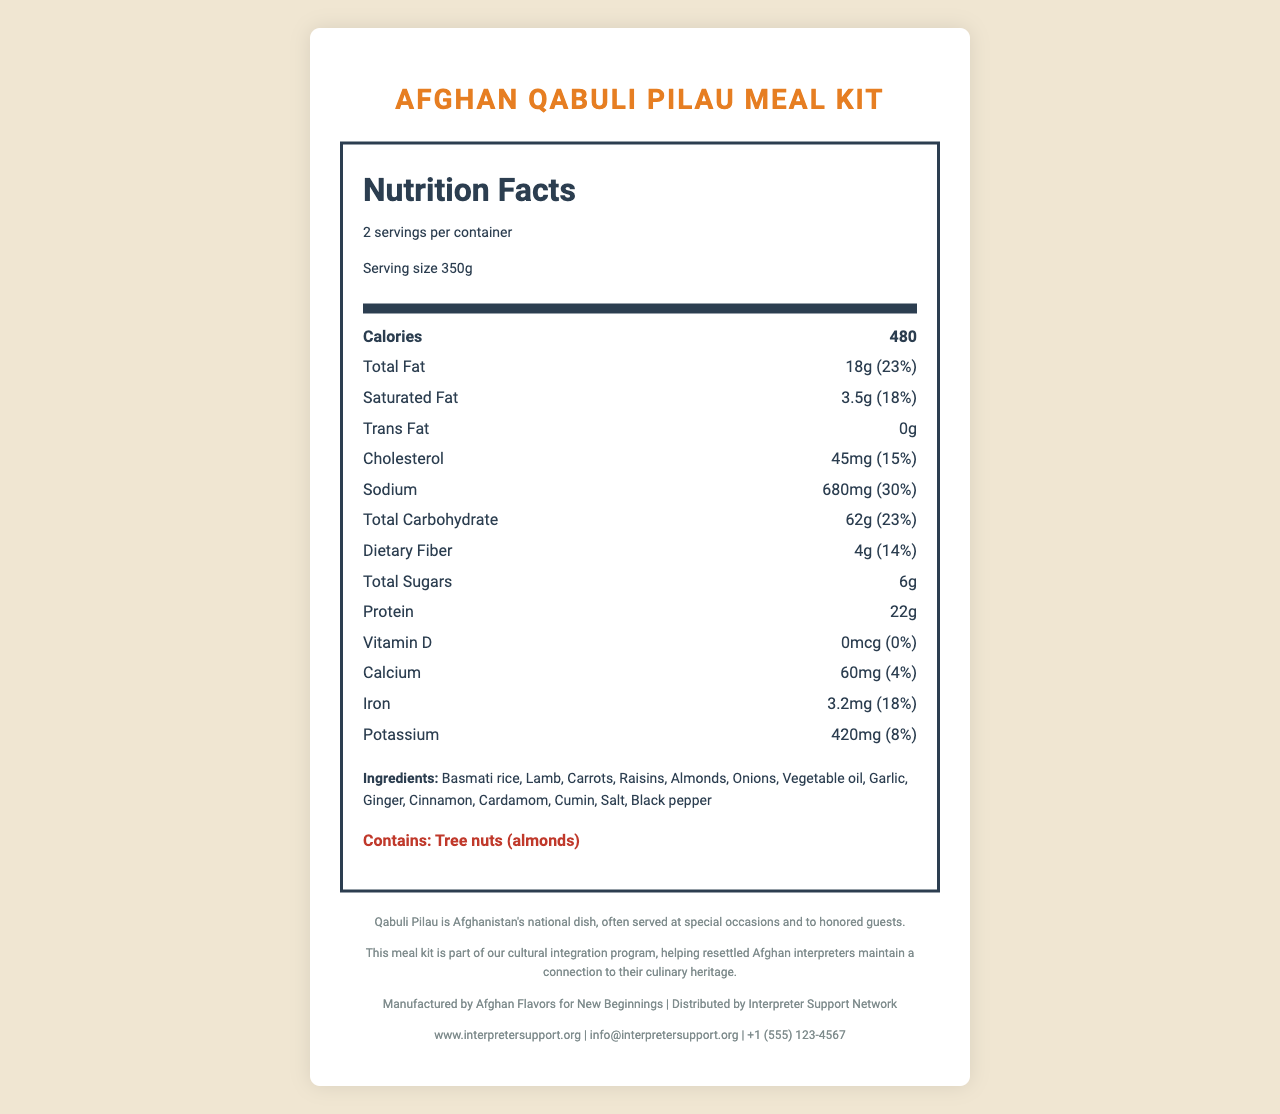what is the serving size for the Afghan Qabuli Pilau Meal Kit? The document specifies that the serving size for the meal kit is 350g.
Answer: 350g how many servings are there per container? The document indicates that there are 2 servings per container.
Answer: 2 how many calories are there in one serving of this meal? The document lists the calories per serving as 480 calories.
Answer: 480 how much protein does one serving contain? It is noted that each serving contains 22g of protein.
Answer: 22g what is the total fat percentage of the daily value per serving? The document states that the total fat per serving is 18g, which is 23% of the daily value.
Answer: 23% what are the allergens listed in the meal kit? The document clearly mentions that the meal kit contains tree nuts (almonds).
Answer: Tree nuts (almonds) how much iron is provided per serving, and what percentage of the daily value does it represent? The document shows that each serving has 3.2mg of iron, representing 18% of the daily value.
Answer: 3.2mg, 18% which ingredient is used first in the preparation instructions? A. Lamb B. Rice C. Onions D. Carrots According to the preparation instructions, onions are the first ingredient to be used, as they are cooked until golden.
Answer: C. Onions how much sodium is there in one serving? A. 450mg B. 600mg C. 680mg D. 750mg The document states that there is 680mg of sodium per serving.
Answer: C. 680mg does the meal kit contain any added sugars? The document indicates that there are 0g of added sugars in the meal kit.
Answer: No what is the cultural significance of the Qabuli Pilau dish? The document explains the cultural significance of Qabuli Pilau as Afghanistan's national dish, commonly served at special occasions and to honored guests.
Answer: Qabuli Pilau is Afghanistan's national dish, often served at special occasions and to honored guests. what are the preparation instructions for the Afghan Qabuli Pilau Meal Kit? The document provides detailed preparation instructions for the Afghan Qabuli Pilau Meal Kit.
Answer: The preparation instructions are: 1. Heat 2 tbsp oil in a large pot. 2. Add onions and cook until golden. 3. Add lamb and spices, cook for 5 minutes. 4. Add rice and water, simmer for 20 minutes. 5. Add carrots, raisins, and almonds. Cook for 10 more minutes. how much dietary fiber is in a serving, and what percentage of the daily value does it represent? The dietary fiber content per serving is 4g, which is 14% of the daily value.
Answer: 4g, 14% who is the manufacturer and distributor of the meal kit? The document specifies that the meal kit is manufactured by Afghan Flavors for New Beginnings and distributed by Interpreter Support Network.
Answer: Manufactured by Afghan Flavors for New Beginnings, Distributed by Interpreter Support Network describe the main idea of the document. The document aims to provide comprehensive information about the Afghan Qabuli Pilau Meal Kit, including its nutritional content, preparation guidelines, cultural importance, and support integration for Afghan interpreters.
Answer: The document presents the Nutrition Facts Label, ingredient list, allergens, preparation and storage instructions, cultural significance, resettlement support message, manufacturer and distributor details, and contact information for the Afghan Qabuli Pilau Meal Kit designed for resettled Afghan interpreters. how much vitamin D is in a serving of the meal kit? The document indicates that there is no vitamin D in a serving of the meal kit, representing 0% of the daily value.
Answer: 0mcg, 0% what is the preparation time for this meal kit? The document provides detailed preparation instructions but does not specify the total preparation time required.
Answer: Unable to determine does this meal kit provide information about supporting resettled Afghan interpreters? The document includes a message stating that the meal kit is part of a cultural integration program to help resettled Afghan interpreters maintain a connection to their culinary heritage.
Answer: Yes 